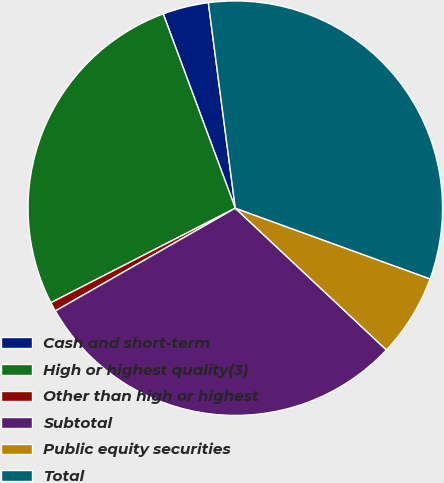Convert chart. <chart><loc_0><loc_0><loc_500><loc_500><pie_chart><fcel>Cash and short-term<fcel>High or highest quality(3)<fcel>Other than high or highest<fcel>Subtotal<fcel>Public equity securities<fcel>Total<nl><fcel>3.58%<fcel>26.89%<fcel>0.72%<fcel>29.75%<fcel>6.45%<fcel>32.62%<nl></chart> 